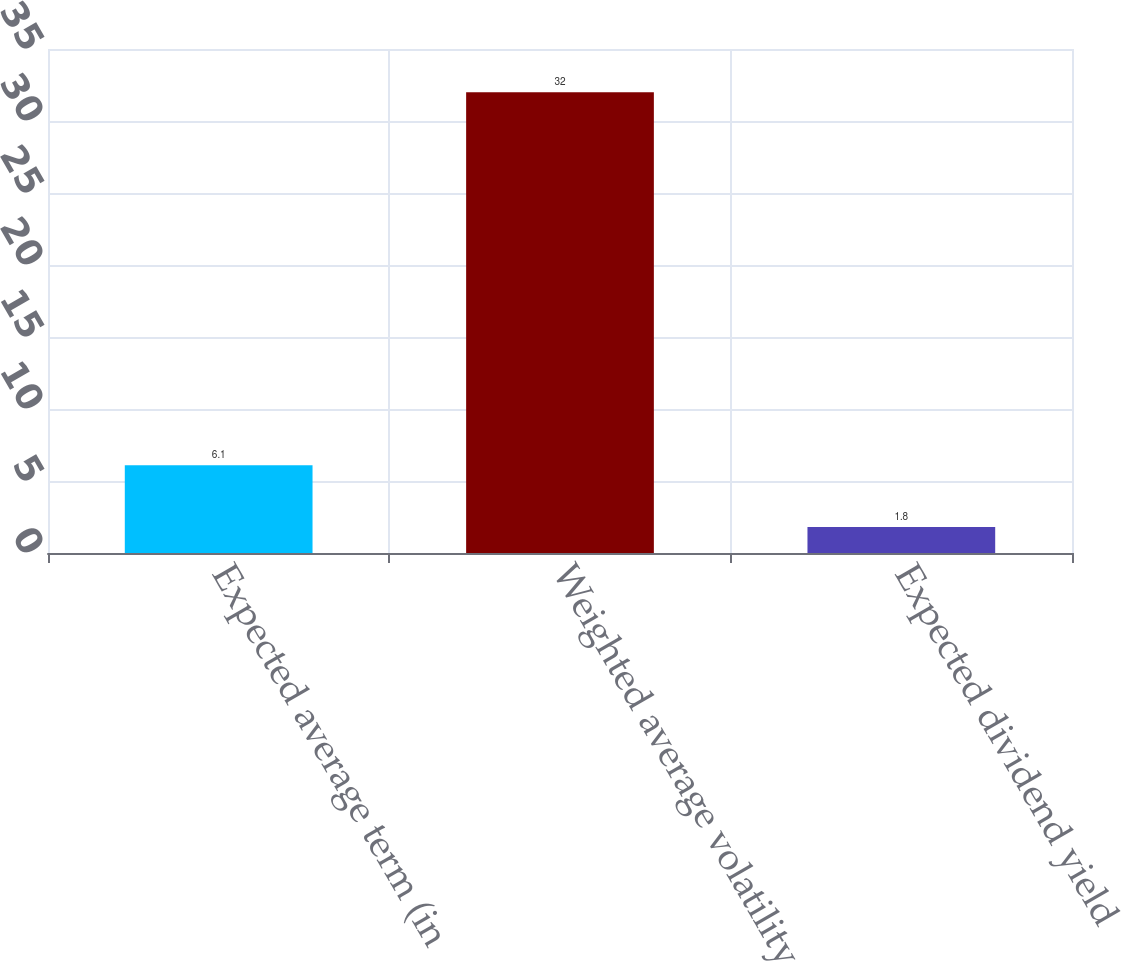Convert chart. <chart><loc_0><loc_0><loc_500><loc_500><bar_chart><fcel>Expected average term (in<fcel>Weighted average volatility<fcel>Expected dividend yield<nl><fcel>6.1<fcel>32<fcel>1.8<nl></chart> 